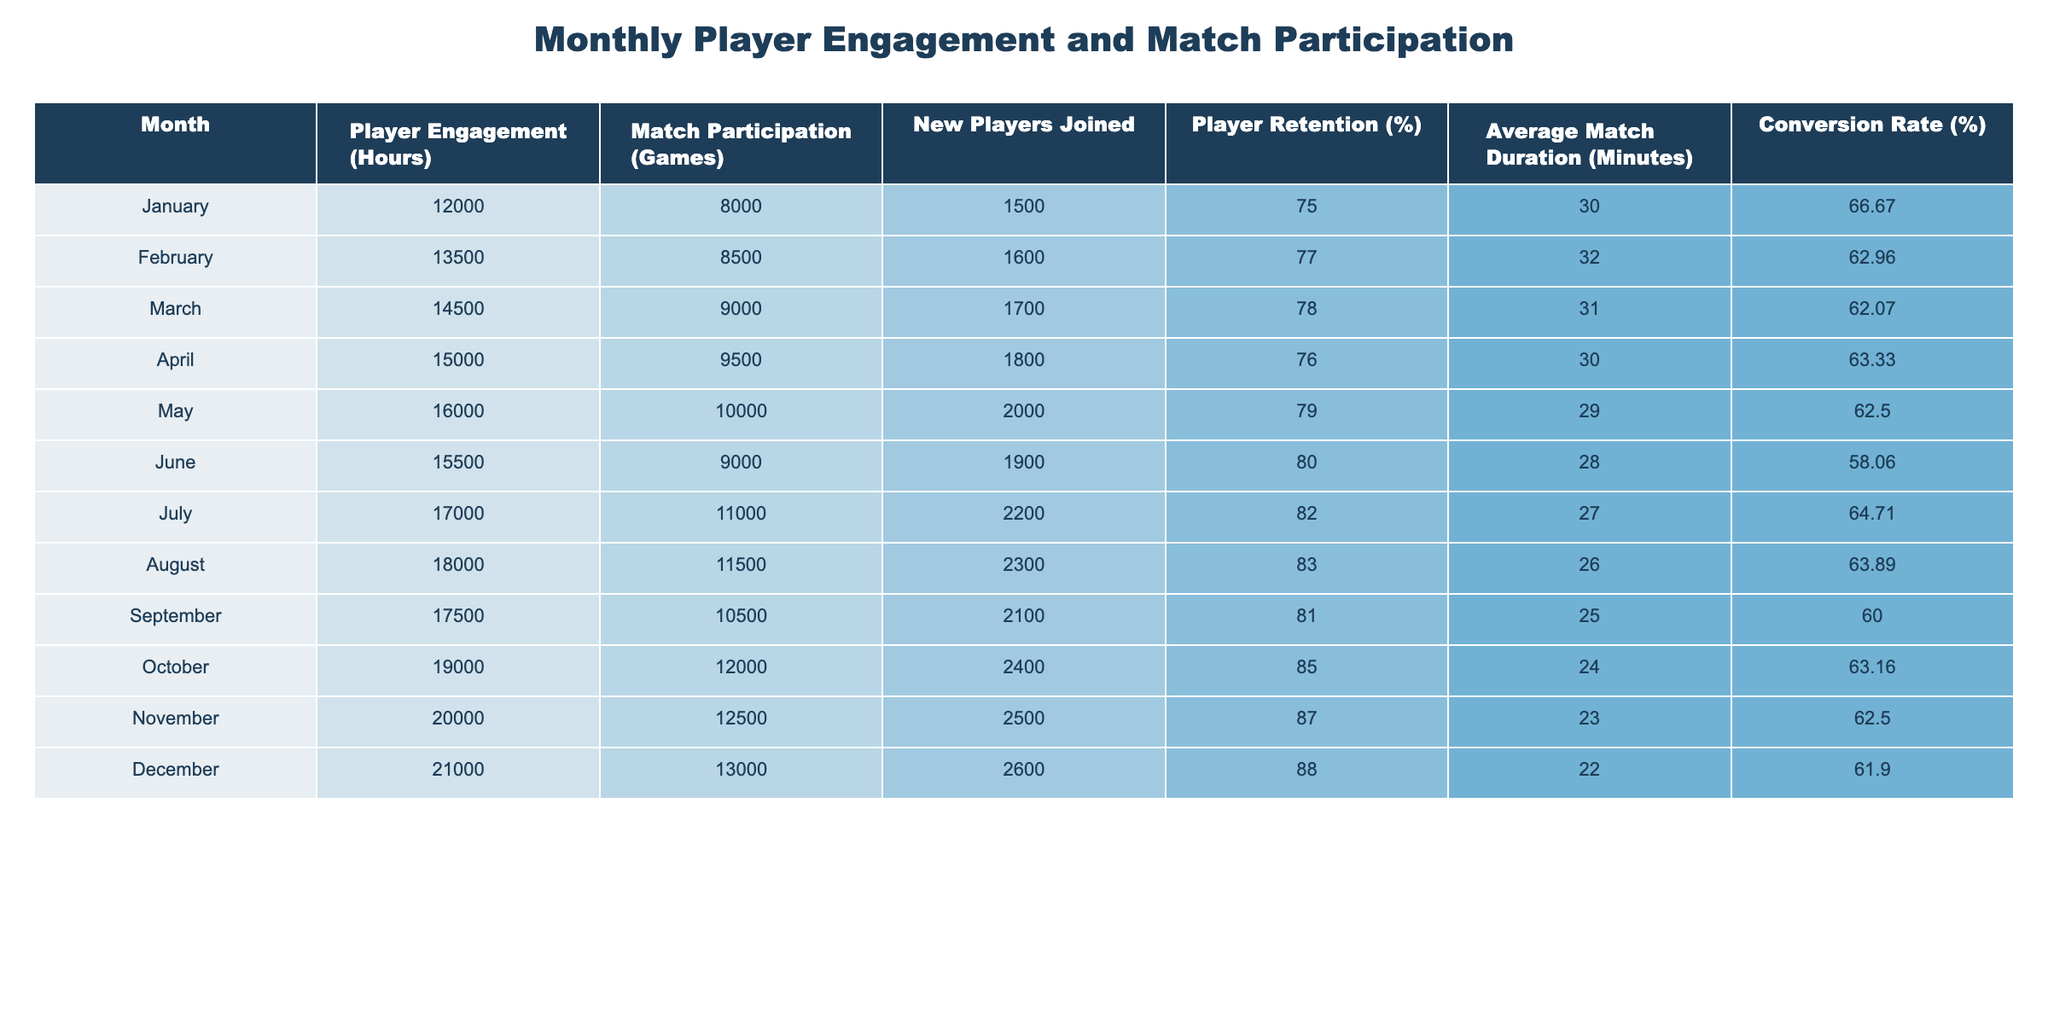What was the month with the highest Player Engagement (Hours)? Looking at the Player Engagement column, December has the highest value at 21000 hours.
Answer: December What is the average Match Participation (Games) over the year? To calculate the average, sum all match participations (sum = 8000 + 8500 + ... + 13000 = 106500) and divide by the number of months (12). The average is 106500 / 12 = 8875.
Answer: 8875 Did Player Retention (%) ever drop below 75% during the year? By reviewing the Player Retention column, the lowest value is 75% in January. Thus, it did not drop below that figure during the year.
Answer: No What was the total number of New Players Joined from May to August? Sum the New Players Joined from May to August: May (2000) + June (1900) + July (2200) + August (2300) = 10400.
Answer: 10400 Which month had the lowest Average Match Duration (Minutes) and what was that value? Scanning the Average Match Duration column, the lowest value is 22 minutes, which occurred in December.
Answer: 22 minutes Is there a consistent upward trend in Player Engagement (Hours) throughout the months? Analyzing the Player Engagement data shows that every month has an increase compared to the previous month except for June, where it dropped from May. Thus, it is not consistent.
Answer: No What is the conversion rate for October? The conversion rate is calculated by taking Match Participation (Games) in October (12000) and dividing it by Player Engagement (Hours) in the same month (19000), then multiplying by 100, which is (12000 / 19000) * 100 = 63.16%.
Answer: 63.16% How much did the Player Engagement (Hours) increase from January to December? The increase is calculated by subtracting January's Player Engagement (12000) from December's (21000), so 21000 - 12000 = 9000.
Answer: 9000 Which month had the highest number of New Players Joined? Comparing the New Players Joined column, December had the highest value of 2600 new players.
Answer: December 